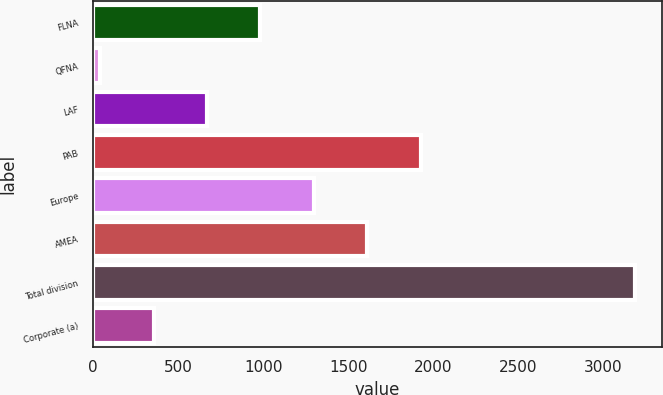Convert chart. <chart><loc_0><loc_0><loc_500><loc_500><bar_chart><fcel>FLNA<fcel>QFNA<fcel>LAF<fcel>PAB<fcel>Europe<fcel>AMEA<fcel>Total division<fcel>Corporate (a)<nl><fcel>984.7<fcel>43<fcel>670.8<fcel>1926.4<fcel>1298.6<fcel>1612.5<fcel>3182<fcel>356.9<nl></chart> 